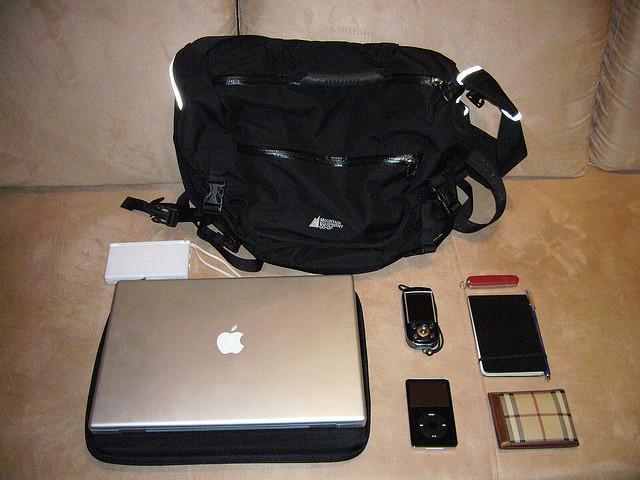How many cell phones are there?
Give a very brief answer. 2. How many people are wearing hats?
Give a very brief answer. 0. 